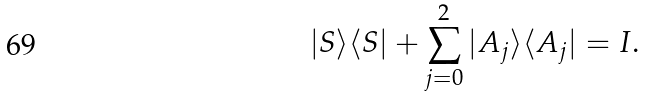<formula> <loc_0><loc_0><loc_500><loc_500>| S \rangle \langle S | + \sum _ { j = 0 } ^ { 2 } | A _ { j } \rangle \langle A _ { j } | = I .</formula> 